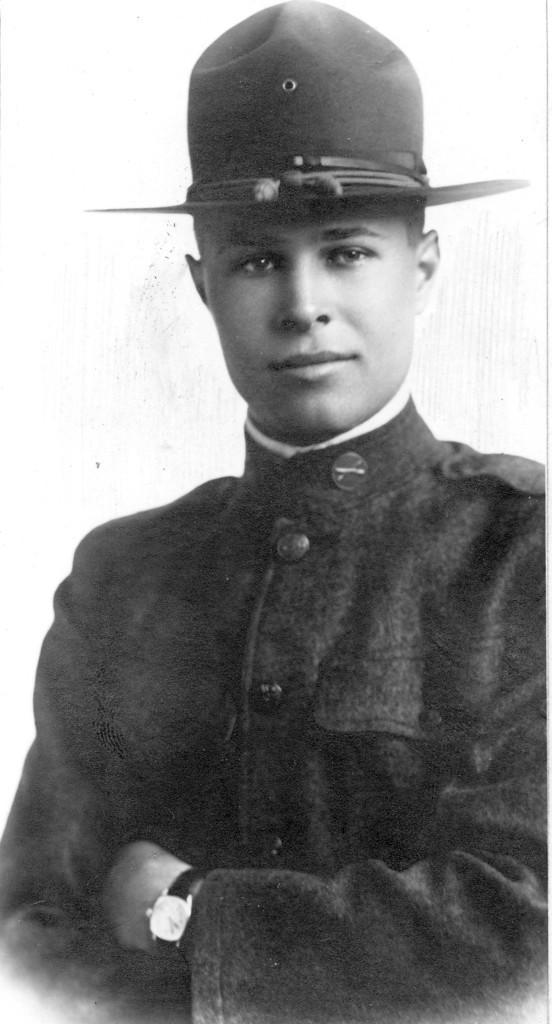In one or two sentences, can you explain what this image depicts? Here in this picture we can see a person wearing a uniform with a hat and we can see the person is smiling and we can see the picture is a black and white image. 